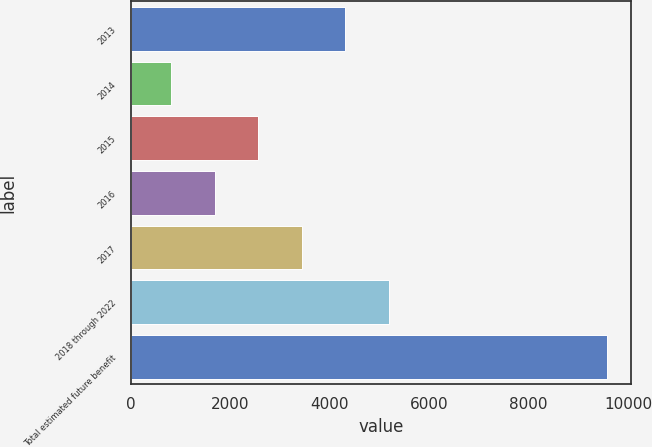<chart> <loc_0><loc_0><loc_500><loc_500><bar_chart><fcel>2013<fcel>2014<fcel>2015<fcel>2016<fcel>2017<fcel>2018 through 2022<fcel>Total estimated future benefit<nl><fcel>4313<fcel>807<fcel>2560<fcel>1683.5<fcel>3436.5<fcel>5189.5<fcel>9572<nl></chart> 